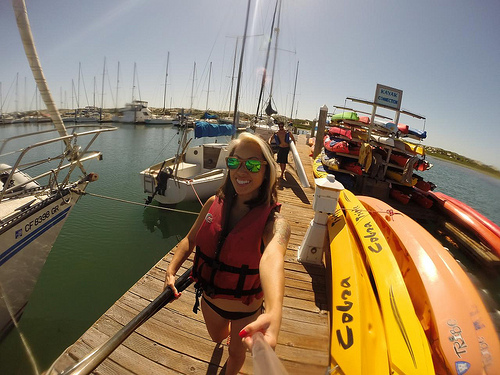<image>
Is there a sky behind the boat? Yes. From this viewpoint, the sky is positioned behind the boat, with the boat partially or fully occluding the sky. 